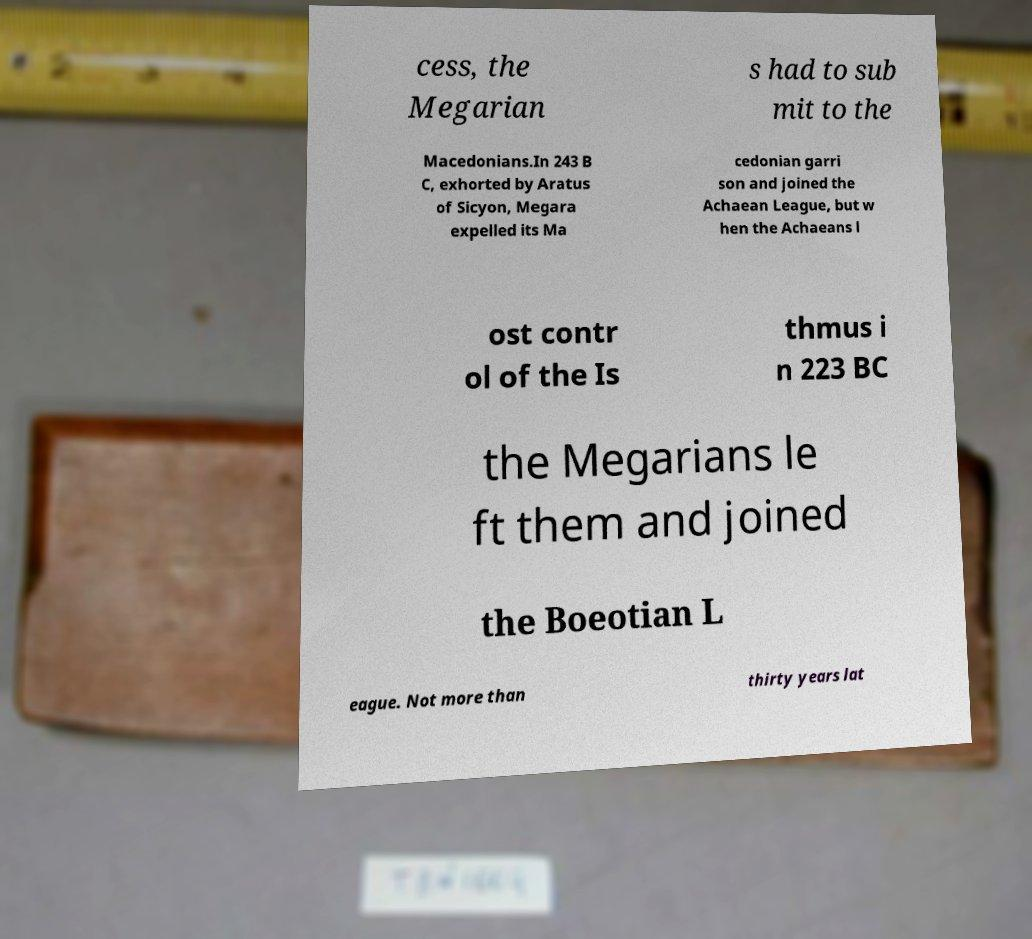There's text embedded in this image that I need extracted. Can you transcribe it verbatim? cess, the Megarian s had to sub mit to the Macedonians.In 243 B C, exhorted by Aratus of Sicyon, Megara expelled its Ma cedonian garri son and joined the Achaean League, but w hen the Achaeans l ost contr ol of the Is thmus i n 223 BC the Megarians le ft them and joined the Boeotian L eague. Not more than thirty years lat 